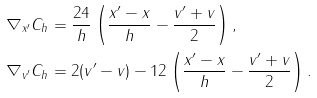<formula> <loc_0><loc_0><loc_500><loc_500>\nabla _ { x ^ { \prime } } C _ { h } & = \frac { 2 4 } { h } \left ( \frac { x ^ { \prime } - x } { h } - \frac { v ^ { \prime } + v } { 2 } \right ) , \\ \nabla _ { v ^ { \prime } } C _ { h } & = 2 ( v ^ { \prime } - v ) - 1 2 \left ( \frac { x ^ { \prime } - x } { h } - \frac { v ^ { \prime } + v } { 2 } \right ) .</formula> 